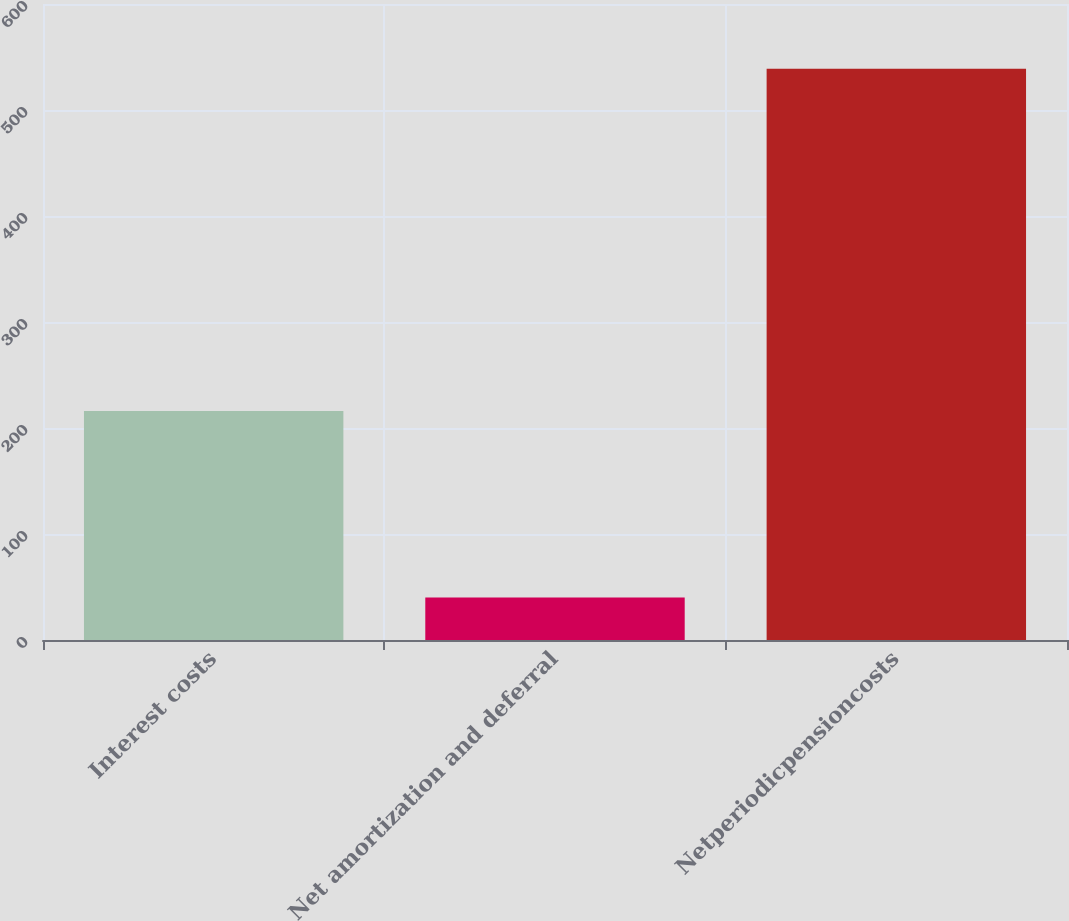Convert chart to OTSL. <chart><loc_0><loc_0><loc_500><loc_500><bar_chart><fcel>Interest costs<fcel>Net amortization and deferral<fcel>Netperiodicpensioncosts<nl><fcel>216<fcel>40<fcel>539<nl></chart> 